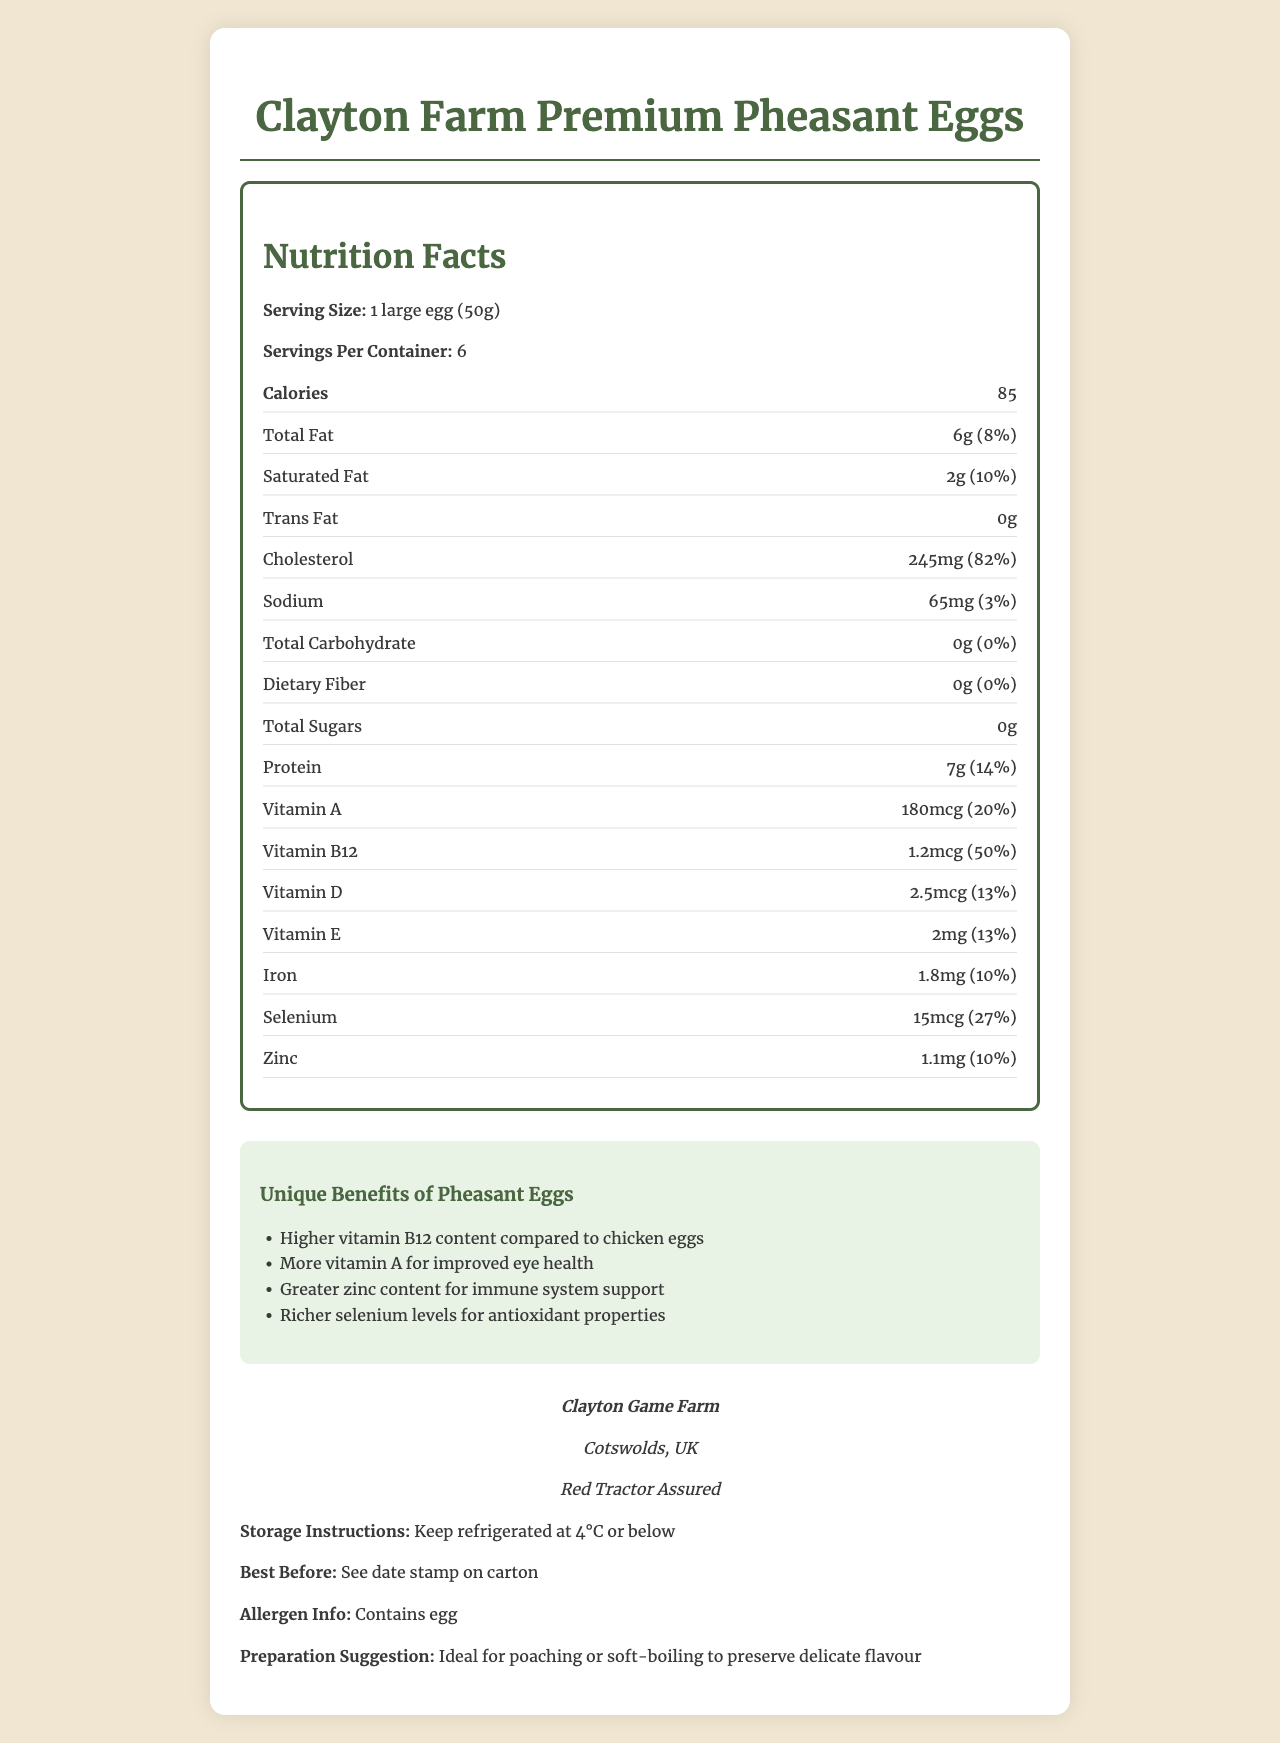what is the product name? The product name is clearly stated at the top of the Nutrition Facts Label.
Answer: Clayton Farm Premium Pheasant Eggs what is the serving size of the pheasant eggs? The serving size is mentioned under the Nutrition Facts section.
Answer: 1 large egg (50g) how much vitamin B12 does one pheasant egg contain? The amount of vitamin B12 is listed in the Nutrition Facts under vitamins.
Answer: 1.2mcg what percentage of daily value does selenium in one pheasant egg contribute? The daily value percentage for selenium is provided in the Nutrition Facts section.
Answer: 27% what is the serving suggestion for the pheasant eggs? The Preparation Suggestion section provides this information at the bottom of the document.
Answer: Ideal for poaching or soft-boiling to preserve delicate flavour which of the following vitamins is NOT listed in the Nutrition Facts? A. Vitamin A B. Vitamin C C. Vitamin D D. Vitamin E Vitamin C is not listed in the Nutrition Facts label.
Answer: B which unique benefit is related to the immune system? A. Higher vitamin B12 content B. More vitamin A for improved eye health C. Greater zinc content D. Richer selenium levels The greater zinc content is stated as beneficial for immune system support.
Answer: C is the document about a product certified by Red Tractor Assured? The certification information under Farm Information indicates Red Tractor Assured.
Answer: Yes identify one key benefit of pheasant eggs compared to chicken eggs. The Unique Benefits section specifically mentions that pheasant eggs have higher vitamin B12 content compared to chicken eggs.
Answer: Higher vitamin B12 content summarize the main idea of the document. The document contains detailed nutritional facts, unique benefits, farm information, storage instructions, and preparation suggestions for pheasant eggs.
Answer: The document provides comprehensive nutritional information about Clayton Farm Premium Pheasant Eggs, highlights their unique benefits compared to chicken eggs, includes storage, allergen info, and preparation suggestions, and mentions the farm's location and certification. what is the daily value percentage of vitamin C in pheasant eggs? The document does not provide any information about the vitamin C content or its daily value percentage.
Answer: Cannot be determined 